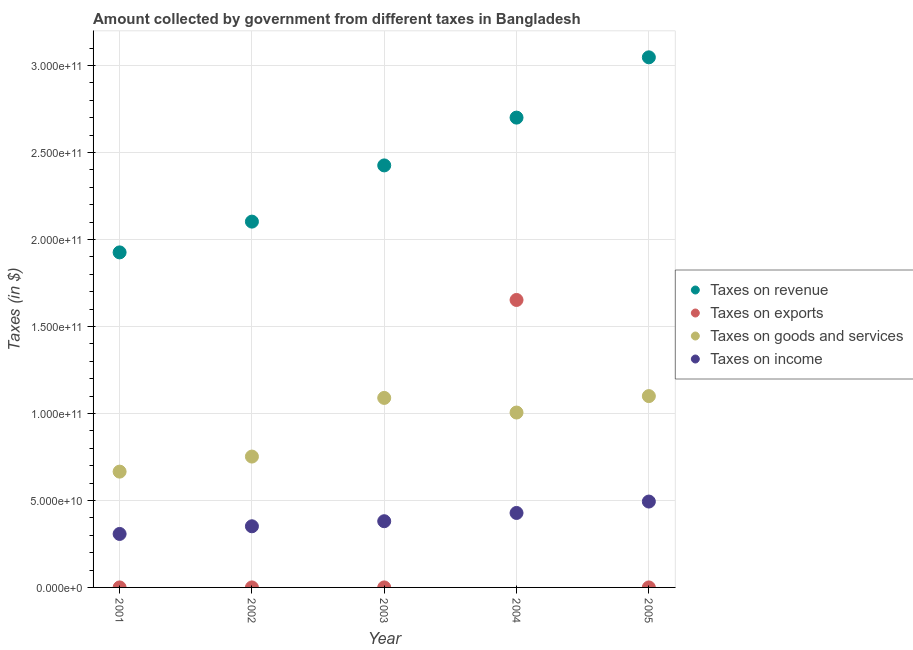How many different coloured dotlines are there?
Keep it short and to the point. 4. Is the number of dotlines equal to the number of legend labels?
Provide a short and direct response. Yes. What is the amount collected as tax on revenue in 2003?
Give a very brief answer. 2.43e+11. Across all years, what is the maximum amount collected as tax on goods?
Your answer should be very brief. 1.10e+11. Across all years, what is the minimum amount collected as tax on goods?
Your answer should be compact. 6.66e+1. In which year was the amount collected as tax on income maximum?
Keep it short and to the point. 2005. In which year was the amount collected as tax on income minimum?
Make the answer very short. 2001. What is the total amount collected as tax on goods in the graph?
Provide a short and direct response. 4.61e+11. What is the difference between the amount collected as tax on goods in 2003 and that in 2005?
Offer a very short reply. -1.04e+09. What is the difference between the amount collected as tax on exports in 2001 and the amount collected as tax on goods in 2004?
Your answer should be very brief. -1.01e+11. What is the average amount collected as tax on exports per year?
Keep it short and to the point. 3.31e+1. In the year 2002, what is the difference between the amount collected as tax on income and amount collected as tax on revenue?
Make the answer very short. -1.75e+11. In how many years, is the amount collected as tax on income greater than 60000000000 $?
Provide a succinct answer. 0. What is the ratio of the amount collected as tax on goods in 2003 to that in 2005?
Your answer should be very brief. 0.99. Is the difference between the amount collected as tax on income in 2001 and 2004 greater than the difference between the amount collected as tax on revenue in 2001 and 2004?
Provide a succinct answer. Yes. What is the difference between the highest and the second highest amount collected as tax on income?
Offer a very short reply. 6.56e+09. What is the difference between the highest and the lowest amount collected as tax on income?
Your response must be concise. 1.86e+1. Is the sum of the amount collected as tax on goods in 2003 and 2004 greater than the maximum amount collected as tax on revenue across all years?
Your answer should be compact. No. Is it the case that in every year, the sum of the amount collected as tax on revenue and amount collected as tax on goods is greater than the sum of amount collected as tax on income and amount collected as tax on exports?
Give a very brief answer. No. Does the amount collected as tax on revenue monotonically increase over the years?
Give a very brief answer. Yes. Is the amount collected as tax on exports strictly greater than the amount collected as tax on goods over the years?
Your answer should be compact. No. How many years are there in the graph?
Provide a succinct answer. 5. Are the values on the major ticks of Y-axis written in scientific E-notation?
Your answer should be compact. Yes. Does the graph contain any zero values?
Offer a very short reply. No. Does the graph contain grids?
Ensure brevity in your answer.  Yes. Where does the legend appear in the graph?
Offer a terse response. Center right. What is the title of the graph?
Offer a very short reply. Amount collected by government from different taxes in Bangladesh. What is the label or title of the Y-axis?
Your answer should be very brief. Taxes (in $). What is the Taxes (in $) in Taxes on revenue in 2001?
Give a very brief answer. 1.93e+11. What is the Taxes (in $) of Taxes on exports in 2001?
Your response must be concise. 2.51e+06. What is the Taxes (in $) in Taxes on goods and services in 2001?
Offer a terse response. 6.66e+1. What is the Taxes (in $) of Taxes on income in 2001?
Your answer should be compact. 3.07e+1. What is the Taxes (in $) in Taxes on revenue in 2002?
Your response must be concise. 2.10e+11. What is the Taxes (in $) in Taxes on goods and services in 2002?
Your answer should be very brief. 7.52e+1. What is the Taxes (in $) in Taxes on income in 2002?
Provide a succinct answer. 3.52e+1. What is the Taxes (in $) of Taxes on revenue in 2003?
Make the answer very short. 2.43e+11. What is the Taxes (in $) in Taxes on exports in 2003?
Provide a short and direct response. 3.38e+05. What is the Taxes (in $) in Taxes on goods and services in 2003?
Provide a succinct answer. 1.09e+11. What is the Taxes (in $) of Taxes on income in 2003?
Offer a terse response. 3.81e+1. What is the Taxes (in $) of Taxes on revenue in 2004?
Keep it short and to the point. 2.70e+11. What is the Taxes (in $) of Taxes on exports in 2004?
Make the answer very short. 1.65e+11. What is the Taxes (in $) in Taxes on goods and services in 2004?
Ensure brevity in your answer.  1.01e+11. What is the Taxes (in $) of Taxes on income in 2004?
Keep it short and to the point. 4.28e+1. What is the Taxes (in $) in Taxes on revenue in 2005?
Give a very brief answer. 3.05e+11. What is the Taxes (in $) of Taxes on exports in 2005?
Provide a succinct answer. 8000. What is the Taxes (in $) of Taxes on goods and services in 2005?
Ensure brevity in your answer.  1.10e+11. What is the Taxes (in $) in Taxes on income in 2005?
Your answer should be very brief. 4.94e+1. Across all years, what is the maximum Taxes (in $) of Taxes on revenue?
Provide a short and direct response. 3.05e+11. Across all years, what is the maximum Taxes (in $) of Taxes on exports?
Give a very brief answer. 1.65e+11. Across all years, what is the maximum Taxes (in $) in Taxes on goods and services?
Provide a short and direct response. 1.10e+11. Across all years, what is the maximum Taxes (in $) in Taxes on income?
Offer a very short reply. 4.94e+1. Across all years, what is the minimum Taxes (in $) in Taxes on revenue?
Offer a terse response. 1.93e+11. Across all years, what is the minimum Taxes (in $) of Taxes on exports?
Make the answer very short. 8000. Across all years, what is the minimum Taxes (in $) of Taxes on goods and services?
Your answer should be very brief. 6.66e+1. Across all years, what is the minimum Taxes (in $) of Taxes on income?
Provide a succinct answer. 3.07e+1. What is the total Taxes (in $) in Taxes on revenue in the graph?
Make the answer very short. 1.22e+12. What is the total Taxes (in $) of Taxes on exports in the graph?
Keep it short and to the point. 1.65e+11. What is the total Taxes (in $) of Taxes on goods and services in the graph?
Offer a very short reply. 4.61e+11. What is the total Taxes (in $) of Taxes on income in the graph?
Provide a short and direct response. 1.96e+11. What is the difference between the Taxes (in $) in Taxes on revenue in 2001 and that in 2002?
Your response must be concise. -1.77e+1. What is the difference between the Taxes (in $) of Taxes on exports in 2001 and that in 2002?
Offer a very short reply. 2.50e+06. What is the difference between the Taxes (in $) of Taxes on goods and services in 2001 and that in 2002?
Ensure brevity in your answer.  -8.66e+09. What is the difference between the Taxes (in $) of Taxes on income in 2001 and that in 2002?
Ensure brevity in your answer.  -4.40e+09. What is the difference between the Taxes (in $) of Taxes on revenue in 2001 and that in 2003?
Offer a very short reply. -5.00e+1. What is the difference between the Taxes (in $) in Taxes on exports in 2001 and that in 2003?
Give a very brief answer. 2.17e+06. What is the difference between the Taxes (in $) of Taxes on goods and services in 2001 and that in 2003?
Provide a short and direct response. -4.24e+1. What is the difference between the Taxes (in $) in Taxes on income in 2001 and that in 2003?
Offer a very short reply. -7.31e+09. What is the difference between the Taxes (in $) of Taxes on revenue in 2001 and that in 2004?
Give a very brief answer. -7.75e+1. What is the difference between the Taxes (in $) in Taxes on exports in 2001 and that in 2004?
Provide a succinct answer. -1.65e+11. What is the difference between the Taxes (in $) of Taxes on goods and services in 2001 and that in 2004?
Offer a very short reply. -3.40e+1. What is the difference between the Taxes (in $) in Taxes on income in 2001 and that in 2004?
Offer a terse response. -1.21e+1. What is the difference between the Taxes (in $) in Taxes on revenue in 2001 and that in 2005?
Your answer should be very brief. -1.12e+11. What is the difference between the Taxes (in $) in Taxes on exports in 2001 and that in 2005?
Keep it short and to the point. 2.50e+06. What is the difference between the Taxes (in $) of Taxes on goods and services in 2001 and that in 2005?
Keep it short and to the point. -4.34e+1. What is the difference between the Taxes (in $) in Taxes on income in 2001 and that in 2005?
Provide a succinct answer. -1.86e+1. What is the difference between the Taxes (in $) in Taxes on revenue in 2002 and that in 2003?
Offer a very short reply. -3.23e+1. What is the difference between the Taxes (in $) in Taxes on exports in 2002 and that in 2003?
Provide a succinct answer. -3.28e+05. What is the difference between the Taxes (in $) in Taxes on goods and services in 2002 and that in 2003?
Your response must be concise. -3.37e+1. What is the difference between the Taxes (in $) in Taxes on income in 2002 and that in 2003?
Your answer should be compact. -2.91e+09. What is the difference between the Taxes (in $) of Taxes on revenue in 2002 and that in 2004?
Your answer should be compact. -5.98e+1. What is the difference between the Taxes (in $) in Taxes on exports in 2002 and that in 2004?
Your response must be concise. -1.65e+11. What is the difference between the Taxes (in $) of Taxes on goods and services in 2002 and that in 2004?
Keep it short and to the point. -2.53e+1. What is the difference between the Taxes (in $) in Taxes on income in 2002 and that in 2004?
Ensure brevity in your answer.  -7.66e+09. What is the difference between the Taxes (in $) in Taxes on revenue in 2002 and that in 2005?
Keep it short and to the point. -9.44e+1. What is the difference between the Taxes (in $) of Taxes on goods and services in 2002 and that in 2005?
Your response must be concise. -3.48e+1. What is the difference between the Taxes (in $) of Taxes on income in 2002 and that in 2005?
Your response must be concise. -1.42e+1. What is the difference between the Taxes (in $) of Taxes on revenue in 2003 and that in 2004?
Your response must be concise. -2.75e+1. What is the difference between the Taxes (in $) in Taxes on exports in 2003 and that in 2004?
Provide a short and direct response. -1.65e+11. What is the difference between the Taxes (in $) of Taxes on goods and services in 2003 and that in 2004?
Provide a succinct answer. 8.41e+09. What is the difference between the Taxes (in $) in Taxes on income in 2003 and that in 2004?
Your answer should be compact. -4.74e+09. What is the difference between the Taxes (in $) of Taxes on revenue in 2003 and that in 2005?
Give a very brief answer. -6.21e+1. What is the difference between the Taxes (in $) of Taxes on exports in 2003 and that in 2005?
Give a very brief answer. 3.30e+05. What is the difference between the Taxes (in $) in Taxes on goods and services in 2003 and that in 2005?
Give a very brief answer. -1.04e+09. What is the difference between the Taxes (in $) of Taxes on income in 2003 and that in 2005?
Give a very brief answer. -1.13e+1. What is the difference between the Taxes (in $) in Taxes on revenue in 2004 and that in 2005?
Offer a terse response. -3.47e+1. What is the difference between the Taxes (in $) of Taxes on exports in 2004 and that in 2005?
Give a very brief answer. 1.65e+11. What is the difference between the Taxes (in $) of Taxes on goods and services in 2004 and that in 2005?
Your answer should be compact. -9.45e+09. What is the difference between the Taxes (in $) in Taxes on income in 2004 and that in 2005?
Keep it short and to the point. -6.56e+09. What is the difference between the Taxes (in $) in Taxes on revenue in 2001 and the Taxes (in $) in Taxes on exports in 2002?
Make the answer very short. 1.93e+11. What is the difference between the Taxes (in $) of Taxes on revenue in 2001 and the Taxes (in $) of Taxes on goods and services in 2002?
Provide a short and direct response. 1.17e+11. What is the difference between the Taxes (in $) of Taxes on revenue in 2001 and the Taxes (in $) of Taxes on income in 2002?
Your response must be concise. 1.57e+11. What is the difference between the Taxes (in $) in Taxes on exports in 2001 and the Taxes (in $) in Taxes on goods and services in 2002?
Your answer should be compact. -7.52e+1. What is the difference between the Taxes (in $) in Taxes on exports in 2001 and the Taxes (in $) in Taxes on income in 2002?
Offer a terse response. -3.51e+1. What is the difference between the Taxes (in $) in Taxes on goods and services in 2001 and the Taxes (in $) in Taxes on income in 2002?
Your answer should be very brief. 3.14e+1. What is the difference between the Taxes (in $) of Taxes on revenue in 2001 and the Taxes (in $) of Taxes on exports in 2003?
Provide a short and direct response. 1.93e+11. What is the difference between the Taxes (in $) of Taxes on revenue in 2001 and the Taxes (in $) of Taxes on goods and services in 2003?
Your answer should be very brief. 8.37e+1. What is the difference between the Taxes (in $) in Taxes on revenue in 2001 and the Taxes (in $) in Taxes on income in 2003?
Offer a terse response. 1.55e+11. What is the difference between the Taxes (in $) in Taxes on exports in 2001 and the Taxes (in $) in Taxes on goods and services in 2003?
Make the answer very short. -1.09e+11. What is the difference between the Taxes (in $) in Taxes on exports in 2001 and the Taxes (in $) in Taxes on income in 2003?
Provide a succinct answer. -3.81e+1. What is the difference between the Taxes (in $) in Taxes on goods and services in 2001 and the Taxes (in $) in Taxes on income in 2003?
Offer a terse response. 2.85e+1. What is the difference between the Taxes (in $) of Taxes on revenue in 2001 and the Taxes (in $) of Taxes on exports in 2004?
Give a very brief answer. 2.73e+1. What is the difference between the Taxes (in $) in Taxes on revenue in 2001 and the Taxes (in $) in Taxes on goods and services in 2004?
Offer a very short reply. 9.21e+1. What is the difference between the Taxes (in $) in Taxes on revenue in 2001 and the Taxes (in $) in Taxes on income in 2004?
Ensure brevity in your answer.  1.50e+11. What is the difference between the Taxes (in $) in Taxes on exports in 2001 and the Taxes (in $) in Taxes on goods and services in 2004?
Offer a terse response. -1.01e+11. What is the difference between the Taxes (in $) in Taxes on exports in 2001 and the Taxes (in $) in Taxes on income in 2004?
Offer a terse response. -4.28e+1. What is the difference between the Taxes (in $) of Taxes on goods and services in 2001 and the Taxes (in $) of Taxes on income in 2004?
Your response must be concise. 2.38e+1. What is the difference between the Taxes (in $) in Taxes on revenue in 2001 and the Taxes (in $) in Taxes on exports in 2005?
Provide a succinct answer. 1.93e+11. What is the difference between the Taxes (in $) of Taxes on revenue in 2001 and the Taxes (in $) of Taxes on goods and services in 2005?
Provide a short and direct response. 8.26e+1. What is the difference between the Taxes (in $) of Taxes on revenue in 2001 and the Taxes (in $) of Taxes on income in 2005?
Offer a very short reply. 1.43e+11. What is the difference between the Taxes (in $) in Taxes on exports in 2001 and the Taxes (in $) in Taxes on goods and services in 2005?
Offer a very short reply. -1.10e+11. What is the difference between the Taxes (in $) of Taxes on exports in 2001 and the Taxes (in $) of Taxes on income in 2005?
Offer a terse response. -4.94e+1. What is the difference between the Taxes (in $) of Taxes on goods and services in 2001 and the Taxes (in $) of Taxes on income in 2005?
Provide a short and direct response. 1.72e+1. What is the difference between the Taxes (in $) in Taxes on revenue in 2002 and the Taxes (in $) in Taxes on exports in 2003?
Your answer should be compact. 2.10e+11. What is the difference between the Taxes (in $) of Taxes on revenue in 2002 and the Taxes (in $) of Taxes on goods and services in 2003?
Make the answer very short. 1.01e+11. What is the difference between the Taxes (in $) of Taxes on revenue in 2002 and the Taxes (in $) of Taxes on income in 2003?
Ensure brevity in your answer.  1.72e+11. What is the difference between the Taxes (in $) in Taxes on exports in 2002 and the Taxes (in $) in Taxes on goods and services in 2003?
Your response must be concise. -1.09e+11. What is the difference between the Taxes (in $) in Taxes on exports in 2002 and the Taxes (in $) in Taxes on income in 2003?
Make the answer very short. -3.81e+1. What is the difference between the Taxes (in $) in Taxes on goods and services in 2002 and the Taxes (in $) in Taxes on income in 2003?
Give a very brief answer. 3.72e+1. What is the difference between the Taxes (in $) in Taxes on revenue in 2002 and the Taxes (in $) in Taxes on exports in 2004?
Provide a short and direct response. 4.50e+1. What is the difference between the Taxes (in $) of Taxes on revenue in 2002 and the Taxes (in $) of Taxes on goods and services in 2004?
Offer a terse response. 1.10e+11. What is the difference between the Taxes (in $) of Taxes on revenue in 2002 and the Taxes (in $) of Taxes on income in 2004?
Give a very brief answer. 1.67e+11. What is the difference between the Taxes (in $) in Taxes on exports in 2002 and the Taxes (in $) in Taxes on goods and services in 2004?
Offer a very short reply. -1.01e+11. What is the difference between the Taxes (in $) in Taxes on exports in 2002 and the Taxes (in $) in Taxes on income in 2004?
Give a very brief answer. -4.28e+1. What is the difference between the Taxes (in $) in Taxes on goods and services in 2002 and the Taxes (in $) in Taxes on income in 2004?
Provide a short and direct response. 3.24e+1. What is the difference between the Taxes (in $) in Taxes on revenue in 2002 and the Taxes (in $) in Taxes on exports in 2005?
Offer a very short reply. 2.10e+11. What is the difference between the Taxes (in $) in Taxes on revenue in 2002 and the Taxes (in $) in Taxes on goods and services in 2005?
Your response must be concise. 1.00e+11. What is the difference between the Taxes (in $) in Taxes on revenue in 2002 and the Taxes (in $) in Taxes on income in 2005?
Offer a terse response. 1.61e+11. What is the difference between the Taxes (in $) in Taxes on exports in 2002 and the Taxes (in $) in Taxes on goods and services in 2005?
Provide a short and direct response. -1.10e+11. What is the difference between the Taxes (in $) in Taxes on exports in 2002 and the Taxes (in $) in Taxes on income in 2005?
Ensure brevity in your answer.  -4.94e+1. What is the difference between the Taxes (in $) of Taxes on goods and services in 2002 and the Taxes (in $) of Taxes on income in 2005?
Your answer should be compact. 2.59e+1. What is the difference between the Taxes (in $) in Taxes on revenue in 2003 and the Taxes (in $) in Taxes on exports in 2004?
Your answer should be compact. 7.74e+1. What is the difference between the Taxes (in $) in Taxes on revenue in 2003 and the Taxes (in $) in Taxes on goods and services in 2004?
Offer a terse response. 1.42e+11. What is the difference between the Taxes (in $) of Taxes on revenue in 2003 and the Taxes (in $) of Taxes on income in 2004?
Your answer should be compact. 2.00e+11. What is the difference between the Taxes (in $) of Taxes on exports in 2003 and the Taxes (in $) of Taxes on goods and services in 2004?
Give a very brief answer. -1.01e+11. What is the difference between the Taxes (in $) in Taxes on exports in 2003 and the Taxes (in $) in Taxes on income in 2004?
Give a very brief answer. -4.28e+1. What is the difference between the Taxes (in $) of Taxes on goods and services in 2003 and the Taxes (in $) of Taxes on income in 2004?
Offer a terse response. 6.61e+1. What is the difference between the Taxes (in $) of Taxes on revenue in 2003 and the Taxes (in $) of Taxes on exports in 2005?
Ensure brevity in your answer.  2.43e+11. What is the difference between the Taxes (in $) of Taxes on revenue in 2003 and the Taxes (in $) of Taxes on goods and services in 2005?
Provide a succinct answer. 1.33e+11. What is the difference between the Taxes (in $) in Taxes on revenue in 2003 and the Taxes (in $) in Taxes on income in 2005?
Offer a terse response. 1.93e+11. What is the difference between the Taxes (in $) of Taxes on exports in 2003 and the Taxes (in $) of Taxes on goods and services in 2005?
Keep it short and to the point. -1.10e+11. What is the difference between the Taxes (in $) in Taxes on exports in 2003 and the Taxes (in $) in Taxes on income in 2005?
Your answer should be compact. -4.94e+1. What is the difference between the Taxes (in $) of Taxes on goods and services in 2003 and the Taxes (in $) of Taxes on income in 2005?
Give a very brief answer. 5.96e+1. What is the difference between the Taxes (in $) of Taxes on revenue in 2004 and the Taxes (in $) of Taxes on exports in 2005?
Provide a succinct answer. 2.70e+11. What is the difference between the Taxes (in $) of Taxes on revenue in 2004 and the Taxes (in $) of Taxes on goods and services in 2005?
Provide a short and direct response. 1.60e+11. What is the difference between the Taxes (in $) of Taxes on revenue in 2004 and the Taxes (in $) of Taxes on income in 2005?
Keep it short and to the point. 2.21e+11. What is the difference between the Taxes (in $) of Taxes on exports in 2004 and the Taxes (in $) of Taxes on goods and services in 2005?
Offer a very short reply. 5.53e+1. What is the difference between the Taxes (in $) in Taxes on exports in 2004 and the Taxes (in $) in Taxes on income in 2005?
Give a very brief answer. 1.16e+11. What is the difference between the Taxes (in $) in Taxes on goods and services in 2004 and the Taxes (in $) in Taxes on income in 2005?
Your response must be concise. 5.12e+1. What is the average Taxes (in $) of Taxes on revenue per year?
Provide a succinct answer. 2.44e+11. What is the average Taxes (in $) in Taxes on exports per year?
Offer a very short reply. 3.31e+1. What is the average Taxes (in $) in Taxes on goods and services per year?
Provide a succinct answer. 9.23e+1. What is the average Taxes (in $) of Taxes on income per year?
Your answer should be very brief. 3.92e+1. In the year 2001, what is the difference between the Taxes (in $) in Taxes on revenue and Taxes (in $) in Taxes on exports?
Offer a very short reply. 1.93e+11. In the year 2001, what is the difference between the Taxes (in $) of Taxes on revenue and Taxes (in $) of Taxes on goods and services?
Your answer should be compact. 1.26e+11. In the year 2001, what is the difference between the Taxes (in $) of Taxes on revenue and Taxes (in $) of Taxes on income?
Your response must be concise. 1.62e+11. In the year 2001, what is the difference between the Taxes (in $) in Taxes on exports and Taxes (in $) in Taxes on goods and services?
Keep it short and to the point. -6.66e+1. In the year 2001, what is the difference between the Taxes (in $) in Taxes on exports and Taxes (in $) in Taxes on income?
Provide a short and direct response. -3.07e+1. In the year 2001, what is the difference between the Taxes (in $) in Taxes on goods and services and Taxes (in $) in Taxes on income?
Make the answer very short. 3.58e+1. In the year 2002, what is the difference between the Taxes (in $) in Taxes on revenue and Taxes (in $) in Taxes on exports?
Provide a succinct answer. 2.10e+11. In the year 2002, what is the difference between the Taxes (in $) of Taxes on revenue and Taxes (in $) of Taxes on goods and services?
Ensure brevity in your answer.  1.35e+11. In the year 2002, what is the difference between the Taxes (in $) of Taxes on revenue and Taxes (in $) of Taxes on income?
Keep it short and to the point. 1.75e+11. In the year 2002, what is the difference between the Taxes (in $) of Taxes on exports and Taxes (in $) of Taxes on goods and services?
Offer a very short reply. -7.52e+1. In the year 2002, what is the difference between the Taxes (in $) in Taxes on exports and Taxes (in $) in Taxes on income?
Make the answer very short. -3.52e+1. In the year 2002, what is the difference between the Taxes (in $) in Taxes on goods and services and Taxes (in $) in Taxes on income?
Your response must be concise. 4.01e+1. In the year 2003, what is the difference between the Taxes (in $) in Taxes on revenue and Taxes (in $) in Taxes on exports?
Make the answer very short. 2.43e+11. In the year 2003, what is the difference between the Taxes (in $) of Taxes on revenue and Taxes (in $) of Taxes on goods and services?
Keep it short and to the point. 1.34e+11. In the year 2003, what is the difference between the Taxes (in $) in Taxes on revenue and Taxes (in $) in Taxes on income?
Provide a succinct answer. 2.05e+11. In the year 2003, what is the difference between the Taxes (in $) in Taxes on exports and Taxes (in $) in Taxes on goods and services?
Give a very brief answer. -1.09e+11. In the year 2003, what is the difference between the Taxes (in $) of Taxes on exports and Taxes (in $) of Taxes on income?
Ensure brevity in your answer.  -3.81e+1. In the year 2003, what is the difference between the Taxes (in $) of Taxes on goods and services and Taxes (in $) of Taxes on income?
Make the answer very short. 7.09e+1. In the year 2004, what is the difference between the Taxes (in $) in Taxes on revenue and Taxes (in $) in Taxes on exports?
Your answer should be very brief. 1.05e+11. In the year 2004, what is the difference between the Taxes (in $) of Taxes on revenue and Taxes (in $) of Taxes on goods and services?
Offer a very short reply. 1.70e+11. In the year 2004, what is the difference between the Taxes (in $) of Taxes on revenue and Taxes (in $) of Taxes on income?
Offer a very short reply. 2.27e+11. In the year 2004, what is the difference between the Taxes (in $) in Taxes on exports and Taxes (in $) in Taxes on goods and services?
Provide a short and direct response. 6.47e+1. In the year 2004, what is the difference between the Taxes (in $) of Taxes on exports and Taxes (in $) of Taxes on income?
Offer a terse response. 1.22e+11. In the year 2004, what is the difference between the Taxes (in $) of Taxes on goods and services and Taxes (in $) of Taxes on income?
Provide a succinct answer. 5.77e+1. In the year 2005, what is the difference between the Taxes (in $) of Taxes on revenue and Taxes (in $) of Taxes on exports?
Your answer should be compact. 3.05e+11. In the year 2005, what is the difference between the Taxes (in $) of Taxes on revenue and Taxes (in $) of Taxes on goods and services?
Provide a succinct answer. 1.95e+11. In the year 2005, what is the difference between the Taxes (in $) in Taxes on revenue and Taxes (in $) in Taxes on income?
Ensure brevity in your answer.  2.55e+11. In the year 2005, what is the difference between the Taxes (in $) of Taxes on exports and Taxes (in $) of Taxes on goods and services?
Offer a very short reply. -1.10e+11. In the year 2005, what is the difference between the Taxes (in $) of Taxes on exports and Taxes (in $) of Taxes on income?
Give a very brief answer. -4.94e+1. In the year 2005, what is the difference between the Taxes (in $) of Taxes on goods and services and Taxes (in $) of Taxes on income?
Give a very brief answer. 6.06e+1. What is the ratio of the Taxes (in $) in Taxes on revenue in 2001 to that in 2002?
Ensure brevity in your answer.  0.92. What is the ratio of the Taxes (in $) of Taxes on exports in 2001 to that in 2002?
Your answer should be compact. 251. What is the ratio of the Taxes (in $) in Taxes on goods and services in 2001 to that in 2002?
Offer a very short reply. 0.88. What is the ratio of the Taxes (in $) in Taxes on income in 2001 to that in 2002?
Provide a succinct answer. 0.87. What is the ratio of the Taxes (in $) of Taxes on revenue in 2001 to that in 2003?
Provide a short and direct response. 0.79. What is the ratio of the Taxes (in $) of Taxes on exports in 2001 to that in 2003?
Offer a terse response. 7.43. What is the ratio of the Taxes (in $) in Taxes on goods and services in 2001 to that in 2003?
Ensure brevity in your answer.  0.61. What is the ratio of the Taxes (in $) of Taxes on income in 2001 to that in 2003?
Offer a very short reply. 0.81. What is the ratio of the Taxes (in $) in Taxes on revenue in 2001 to that in 2004?
Your answer should be compact. 0.71. What is the ratio of the Taxes (in $) in Taxes on exports in 2001 to that in 2004?
Offer a terse response. 0. What is the ratio of the Taxes (in $) in Taxes on goods and services in 2001 to that in 2004?
Your answer should be very brief. 0.66. What is the ratio of the Taxes (in $) of Taxes on income in 2001 to that in 2004?
Provide a succinct answer. 0.72. What is the ratio of the Taxes (in $) in Taxes on revenue in 2001 to that in 2005?
Your answer should be compact. 0.63. What is the ratio of the Taxes (in $) of Taxes on exports in 2001 to that in 2005?
Keep it short and to the point. 313.75. What is the ratio of the Taxes (in $) of Taxes on goods and services in 2001 to that in 2005?
Offer a very short reply. 0.61. What is the ratio of the Taxes (in $) of Taxes on income in 2001 to that in 2005?
Ensure brevity in your answer.  0.62. What is the ratio of the Taxes (in $) in Taxes on revenue in 2002 to that in 2003?
Your answer should be compact. 0.87. What is the ratio of the Taxes (in $) of Taxes on exports in 2002 to that in 2003?
Provide a short and direct response. 0.03. What is the ratio of the Taxes (in $) of Taxes on goods and services in 2002 to that in 2003?
Offer a terse response. 0.69. What is the ratio of the Taxes (in $) of Taxes on income in 2002 to that in 2003?
Your response must be concise. 0.92. What is the ratio of the Taxes (in $) in Taxes on revenue in 2002 to that in 2004?
Ensure brevity in your answer.  0.78. What is the ratio of the Taxes (in $) in Taxes on exports in 2002 to that in 2004?
Your answer should be very brief. 0. What is the ratio of the Taxes (in $) of Taxes on goods and services in 2002 to that in 2004?
Give a very brief answer. 0.75. What is the ratio of the Taxes (in $) in Taxes on income in 2002 to that in 2004?
Offer a terse response. 0.82. What is the ratio of the Taxes (in $) in Taxes on revenue in 2002 to that in 2005?
Offer a terse response. 0.69. What is the ratio of the Taxes (in $) of Taxes on goods and services in 2002 to that in 2005?
Your answer should be compact. 0.68. What is the ratio of the Taxes (in $) of Taxes on income in 2002 to that in 2005?
Provide a short and direct response. 0.71. What is the ratio of the Taxes (in $) in Taxes on revenue in 2003 to that in 2004?
Ensure brevity in your answer.  0.9. What is the ratio of the Taxes (in $) in Taxes on exports in 2003 to that in 2004?
Make the answer very short. 0. What is the ratio of the Taxes (in $) in Taxes on goods and services in 2003 to that in 2004?
Keep it short and to the point. 1.08. What is the ratio of the Taxes (in $) of Taxes on income in 2003 to that in 2004?
Your response must be concise. 0.89. What is the ratio of the Taxes (in $) of Taxes on revenue in 2003 to that in 2005?
Provide a short and direct response. 0.8. What is the ratio of the Taxes (in $) in Taxes on exports in 2003 to that in 2005?
Provide a succinct answer. 42.25. What is the ratio of the Taxes (in $) in Taxes on goods and services in 2003 to that in 2005?
Ensure brevity in your answer.  0.99. What is the ratio of the Taxes (in $) in Taxes on income in 2003 to that in 2005?
Your response must be concise. 0.77. What is the ratio of the Taxes (in $) in Taxes on revenue in 2004 to that in 2005?
Provide a succinct answer. 0.89. What is the ratio of the Taxes (in $) of Taxes on exports in 2004 to that in 2005?
Offer a terse response. 2.07e+07. What is the ratio of the Taxes (in $) of Taxes on goods and services in 2004 to that in 2005?
Your response must be concise. 0.91. What is the ratio of the Taxes (in $) of Taxes on income in 2004 to that in 2005?
Ensure brevity in your answer.  0.87. What is the difference between the highest and the second highest Taxes (in $) of Taxes on revenue?
Offer a terse response. 3.47e+1. What is the difference between the highest and the second highest Taxes (in $) of Taxes on exports?
Your response must be concise. 1.65e+11. What is the difference between the highest and the second highest Taxes (in $) of Taxes on goods and services?
Your response must be concise. 1.04e+09. What is the difference between the highest and the second highest Taxes (in $) of Taxes on income?
Keep it short and to the point. 6.56e+09. What is the difference between the highest and the lowest Taxes (in $) in Taxes on revenue?
Give a very brief answer. 1.12e+11. What is the difference between the highest and the lowest Taxes (in $) of Taxes on exports?
Offer a terse response. 1.65e+11. What is the difference between the highest and the lowest Taxes (in $) in Taxes on goods and services?
Give a very brief answer. 4.34e+1. What is the difference between the highest and the lowest Taxes (in $) of Taxes on income?
Ensure brevity in your answer.  1.86e+1. 